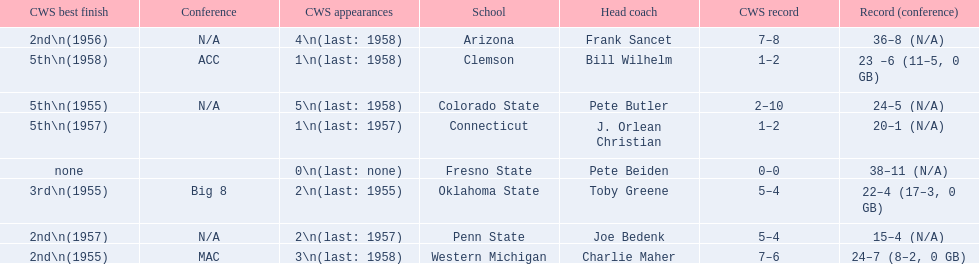How many cws appearances does clemson have? 1\n(last: 1958). Help me parse the entirety of this table. {'header': ['CWS best finish', 'Conference', 'CWS appearances', 'School', 'Head coach', 'CWS record', 'Record (conference)'], 'rows': [['2nd\\n(1956)', 'N/A', '4\\n(last: 1958)', 'Arizona', 'Frank Sancet', '7–8', '36–8 (N/A)'], ['5th\\n(1958)', 'ACC', '1\\n(last: 1958)', 'Clemson', 'Bill Wilhelm', '1–2', '23 –6 (11–5, 0 GB)'], ['5th\\n(1955)', 'N/A', '5\\n(last: 1958)', 'Colorado State', 'Pete Butler', '2–10', '24–5 (N/A)'], ['5th\\n(1957)', '', '1\\n(last: 1957)', 'Connecticut', 'J. Orlean Christian', '1–2', '20–1 (N/A)'], ['none', '', '0\\n(last: none)', 'Fresno State', 'Pete Beiden', '0–0', '38–11 (N/A)'], ['3rd\\n(1955)', 'Big 8', '2\\n(last: 1955)', 'Oklahoma State', 'Toby Greene', '5–4', '22–4 (17–3, 0 GB)'], ['2nd\\n(1957)', 'N/A', '2\\n(last: 1957)', 'Penn State', 'Joe Bedenk', '5–4', '15–4 (N/A)'], ['2nd\\n(1955)', 'MAC', '3\\n(last: 1958)', 'Western Michigan', 'Charlie Maher', '7–6', '24–7 (8–2, 0 GB)']]} How many cws appearances does western michigan have? 3\n(last: 1958). Which of these schools has more cws appearances? Western Michigan. 